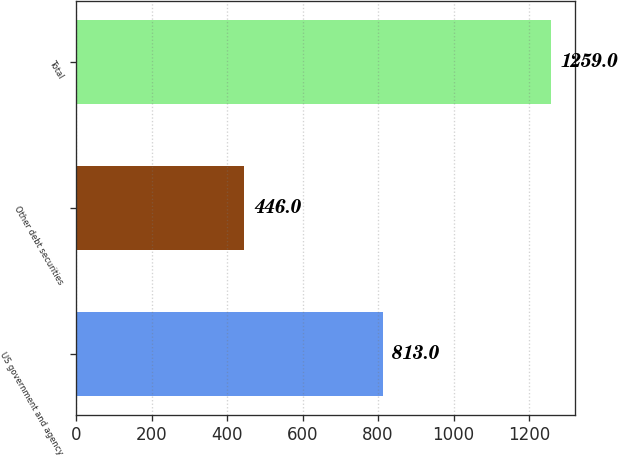<chart> <loc_0><loc_0><loc_500><loc_500><bar_chart><fcel>US government and agency<fcel>Other debt securities<fcel>Total<nl><fcel>813<fcel>446<fcel>1259<nl></chart> 